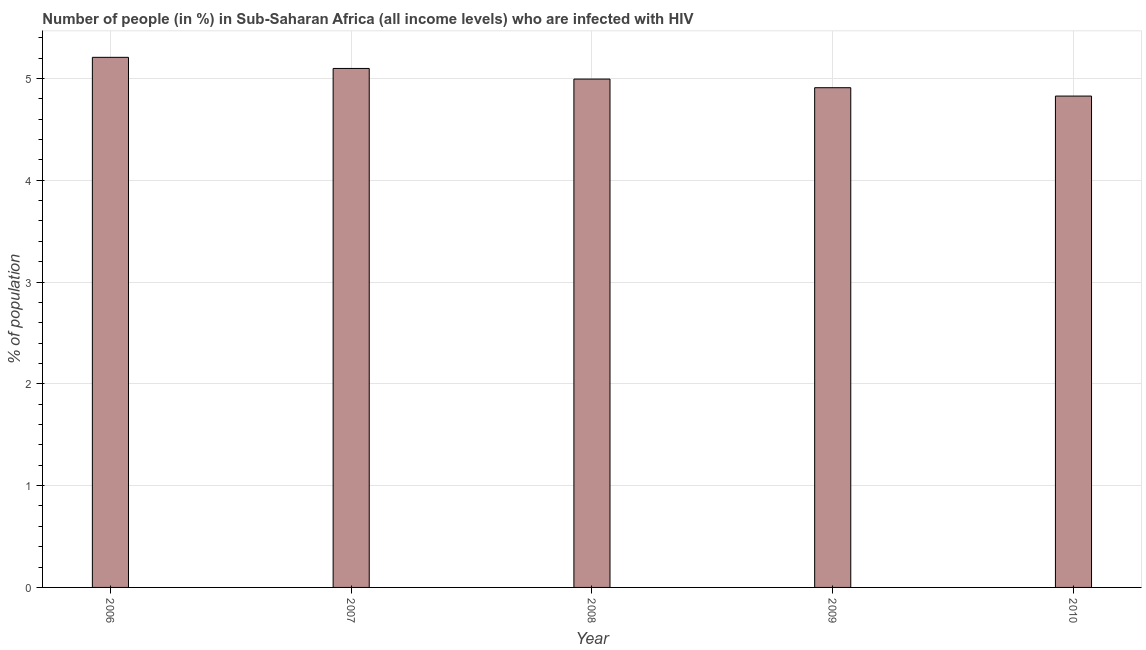Does the graph contain grids?
Provide a short and direct response. Yes. What is the title of the graph?
Provide a succinct answer. Number of people (in %) in Sub-Saharan Africa (all income levels) who are infected with HIV. What is the label or title of the X-axis?
Keep it short and to the point. Year. What is the label or title of the Y-axis?
Make the answer very short. % of population. What is the number of people infected with hiv in 2008?
Your answer should be compact. 4.99. Across all years, what is the maximum number of people infected with hiv?
Make the answer very short. 5.21. Across all years, what is the minimum number of people infected with hiv?
Your answer should be very brief. 4.83. What is the sum of the number of people infected with hiv?
Keep it short and to the point. 25.03. What is the difference between the number of people infected with hiv in 2006 and 2010?
Your response must be concise. 0.38. What is the average number of people infected with hiv per year?
Provide a short and direct response. 5.01. What is the median number of people infected with hiv?
Ensure brevity in your answer.  4.99. Do a majority of the years between 2009 and 2007 (inclusive) have number of people infected with hiv greater than 4.4 %?
Your response must be concise. Yes. What is the ratio of the number of people infected with hiv in 2007 to that in 2009?
Ensure brevity in your answer.  1.04. Is the difference between the number of people infected with hiv in 2008 and 2010 greater than the difference between any two years?
Make the answer very short. No. What is the difference between the highest and the second highest number of people infected with hiv?
Your answer should be compact. 0.11. What is the difference between the highest and the lowest number of people infected with hiv?
Provide a succinct answer. 0.38. How many bars are there?
Provide a succinct answer. 5. Are the values on the major ticks of Y-axis written in scientific E-notation?
Your answer should be compact. No. What is the % of population in 2006?
Your response must be concise. 5.21. What is the % of population of 2007?
Make the answer very short. 5.1. What is the % of population of 2008?
Provide a short and direct response. 4.99. What is the % of population in 2009?
Give a very brief answer. 4.91. What is the % of population in 2010?
Keep it short and to the point. 4.83. What is the difference between the % of population in 2006 and 2007?
Make the answer very short. 0.11. What is the difference between the % of population in 2006 and 2008?
Ensure brevity in your answer.  0.21. What is the difference between the % of population in 2006 and 2009?
Provide a short and direct response. 0.3. What is the difference between the % of population in 2006 and 2010?
Provide a succinct answer. 0.38. What is the difference between the % of population in 2007 and 2008?
Your answer should be compact. 0.1. What is the difference between the % of population in 2007 and 2009?
Keep it short and to the point. 0.19. What is the difference between the % of population in 2007 and 2010?
Your answer should be compact. 0.27. What is the difference between the % of population in 2008 and 2009?
Give a very brief answer. 0.08. What is the difference between the % of population in 2008 and 2010?
Make the answer very short. 0.17. What is the difference between the % of population in 2009 and 2010?
Give a very brief answer. 0.08. What is the ratio of the % of population in 2006 to that in 2008?
Make the answer very short. 1.04. What is the ratio of the % of population in 2006 to that in 2009?
Your answer should be compact. 1.06. What is the ratio of the % of population in 2006 to that in 2010?
Your response must be concise. 1.08. What is the ratio of the % of population in 2007 to that in 2009?
Offer a terse response. 1.04. What is the ratio of the % of population in 2007 to that in 2010?
Give a very brief answer. 1.06. What is the ratio of the % of population in 2008 to that in 2009?
Keep it short and to the point. 1.02. What is the ratio of the % of population in 2008 to that in 2010?
Keep it short and to the point. 1.03. 